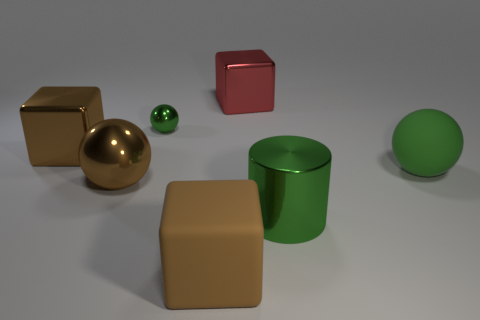Subtract all cyan blocks. Subtract all blue cylinders. How many blocks are left? 3 Add 2 green objects. How many objects exist? 9 Subtract all cylinders. How many objects are left? 6 Add 2 blue rubber cylinders. How many blue rubber cylinders exist? 2 Subtract 0 purple cubes. How many objects are left? 7 Subtract all big green things. Subtract all tiny cyan spheres. How many objects are left? 5 Add 2 big green objects. How many big green objects are left? 4 